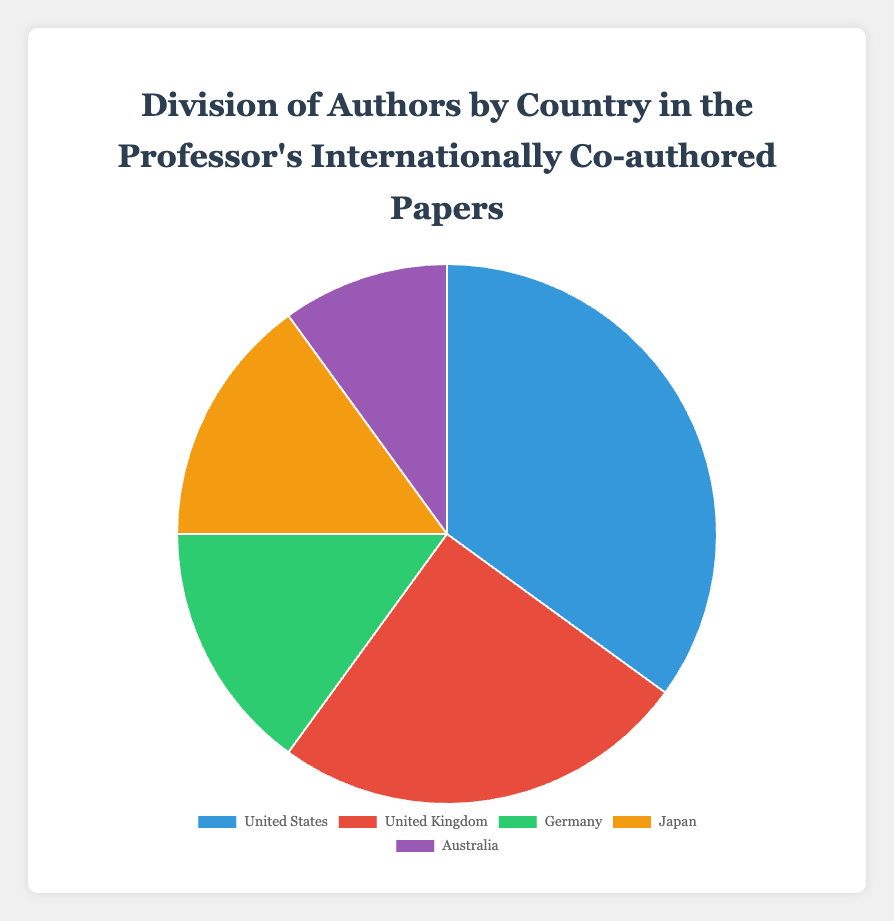What percentage of the authors are from Japan and Germany combined? To find the combined percentage of authors from Japan and Germany, sum the individual percentages of those two countries. Japan has 15% and Germany also has 15%. So, 15% + 15% = 30%.
Answer: 30% Which country has the highest percentage of authors? Look at the divisions in the pie chart and identify the country with the largest segment. The United States has the largest segment, representing 35% of authors.
Answer: United States Which country has the smallest slice in the pie chart? Identify the smallest segment in the pie chart to determine the country it represents. Australia, with 10% of authors, has the smallest slice.
Answer: Australia How does the percentage of authors from the United Kingdom compare to those from Australia? Compare the two given percentages. The United Kingdom has 25% while Australia has 10%. Therefore, the United Kingdom has a higher percentage.
Answer: United Kingdom has a higher percentage What is the difference in author percentage between the United States and the United Kingdom? Subtract the percentage of authors from the United Kingdom from the percentage of authors from the United States. 35% - 25% = 10%.
Answer: 10% What fraction of the total authors are from countries other than the United States? Calculate the combined percentage of authors from the United Kingdom, Germany, Japan, and Australia, and convert this to a fraction. (25% + 15% + 15% + 10% = 65%) which is 65/100 or 13/20.
Answer: 13/20 Which two countries together make up more than half of the total authors? Sum combinations of percentages for country pairs and find those that add up to more than 50%. The United States (35%) and United Kingdom (25%) combined make up 60%, which is more than half.
Answer: United States and United Kingdom Which country has the third-largest percentage of authors? Identify the countries by their segments and sort them in descending order by percentage. The countries are United States (35%), United Kingdom (25%), and then both Germany and Japan are tied at 15%. Therefore, either Germany or Japan would be the correct answer.
Answer: Germany or Japan If we combine the European countries (United Kingdom and Germany), what percentage of authors does this represent? Sum the percentages for the United Kingdom and Germany. 25% (United Kingdom) + 15% (Germany) = 40%.
Answer: 40% How much larger is the segment for the United States than the segment for Australia? Compare the percentages representing the United States and Australia. Subtract Australia’s percentage from the United States’ percentage. 35% - 10% = 25%.
Answer: 25% 